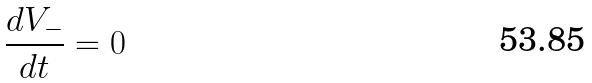Convert formula to latex. <formula><loc_0><loc_0><loc_500><loc_500>\frac { d V _ { - } } { d t } = 0</formula> 